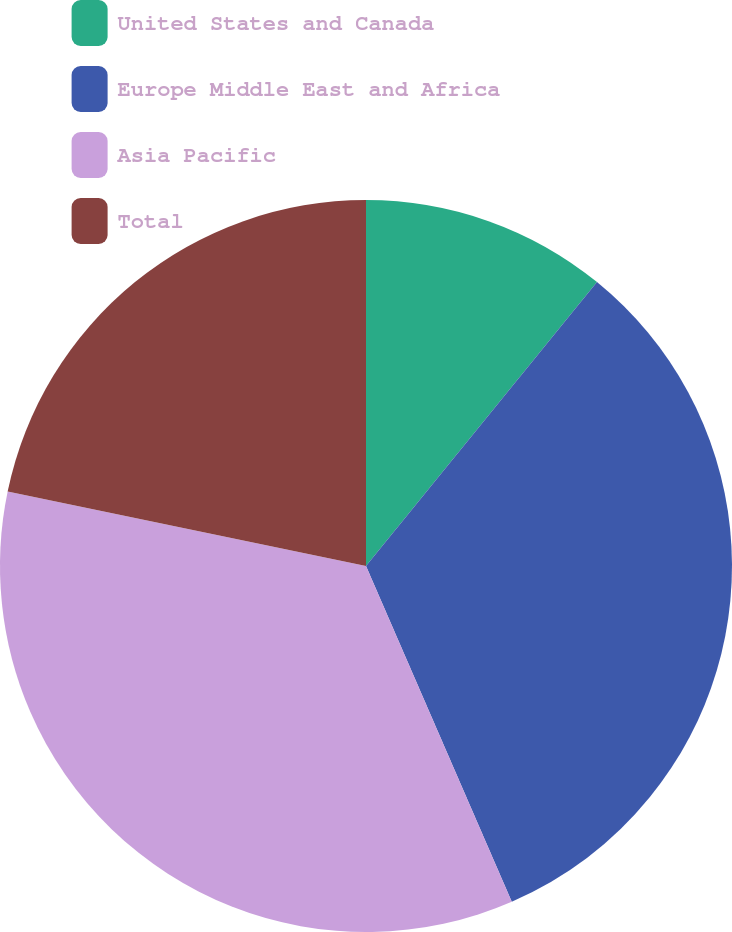<chart> <loc_0><loc_0><loc_500><loc_500><pie_chart><fcel>United States and Canada<fcel>Europe Middle East and Africa<fcel>Asia Pacific<fcel>Total<nl><fcel>10.87%<fcel>32.61%<fcel>34.78%<fcel>21.74%<nl></chart> 